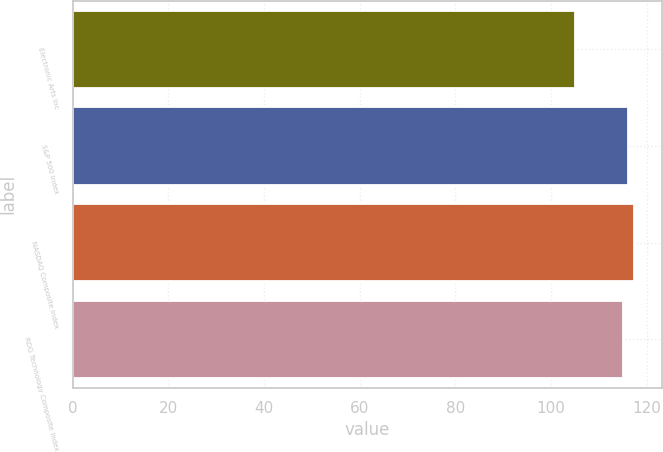Convert chart to OTSL. <chart><loc_0><loc_0><loc_500><loc_500><bar_chart><fcel>Electronic Arts Inc<fcel>S&P 500 Index<fcel>NASDAQ Composite Index<fcel>RDG Technology Composite Index<nl><fcel>105<fcel>116.2<fcel>117.4<fcel>115<nl></chart> 